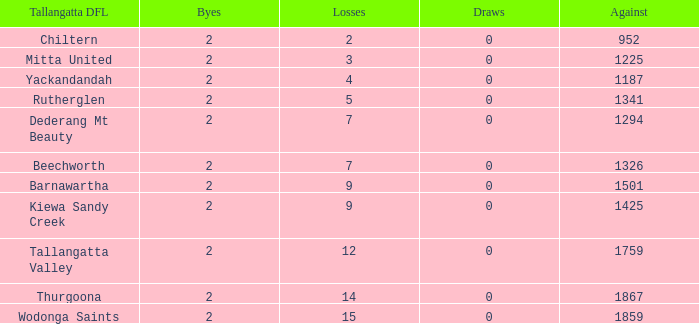What is the most byes with 11 wins and fewer than 1867 againsts? 2.0. 